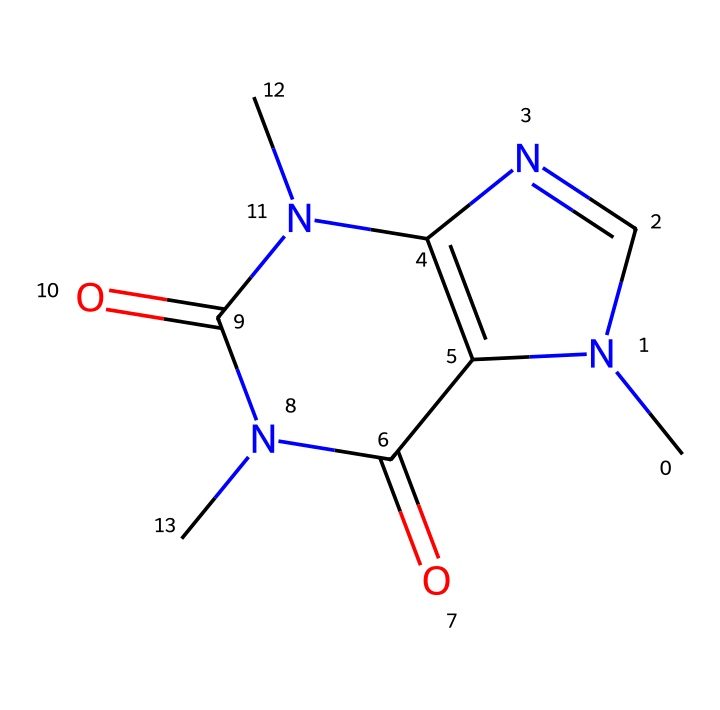What is the molecular formula of caffeine? To determine the molecular formula from the provided SMILES, we can count the number of each type of atom present. In the structure, there are 8 Carbon (C), 10 Hydrogen (H), 4 Nitrogen (N), and 2 Oxygen (O) atoms. Combining these, the molecular formula is C8H10N4O2.
Answer: C8H10N4O2 How many nitrogen atoms are present in the caffeine structure? By examining the SMILES code, we can identify that the nitrogen atoms are represented as 'N'. Counting them in the structure, there are a total of 4 nitrogen atoms present.
Answer: 4 Does caffeine exhibit any acidic properties? Caffeine contains nitrogen atoms which can engage in protonation but does not have carboxylic acid groups (−COOH), indicating it is not substantially acidic. Therefore, it does not exhibit strong acidic properties.
Answer: No What type of non-electrolyte is caffeine considered? Caffeine is classified as an alkaloid, a type of non-electrolyte that typically has physiological effects and is derived from plants. This classification comes from its nitrogen-containing bases and is common in organisms as a stimulant.
Answer: alkaloid How many rings are present in the caffeine structure? The structure of caffeine consists of two fused rings typical of purine derivatives. By analyzing the connectivity, we can confirm that there are a total of 2 aromatic rings in the structure.
Answer: 2 What is the significance of the carbonyl groups in caffeine? The carbonyl groups (C=O) indicated in the structure contribute to the molecule's polar character, allowing for hydrogen bonding and affecting its solubility and interactions in biological systems. This also aids in its ability to act as a stimulant.
Answer: polar character 